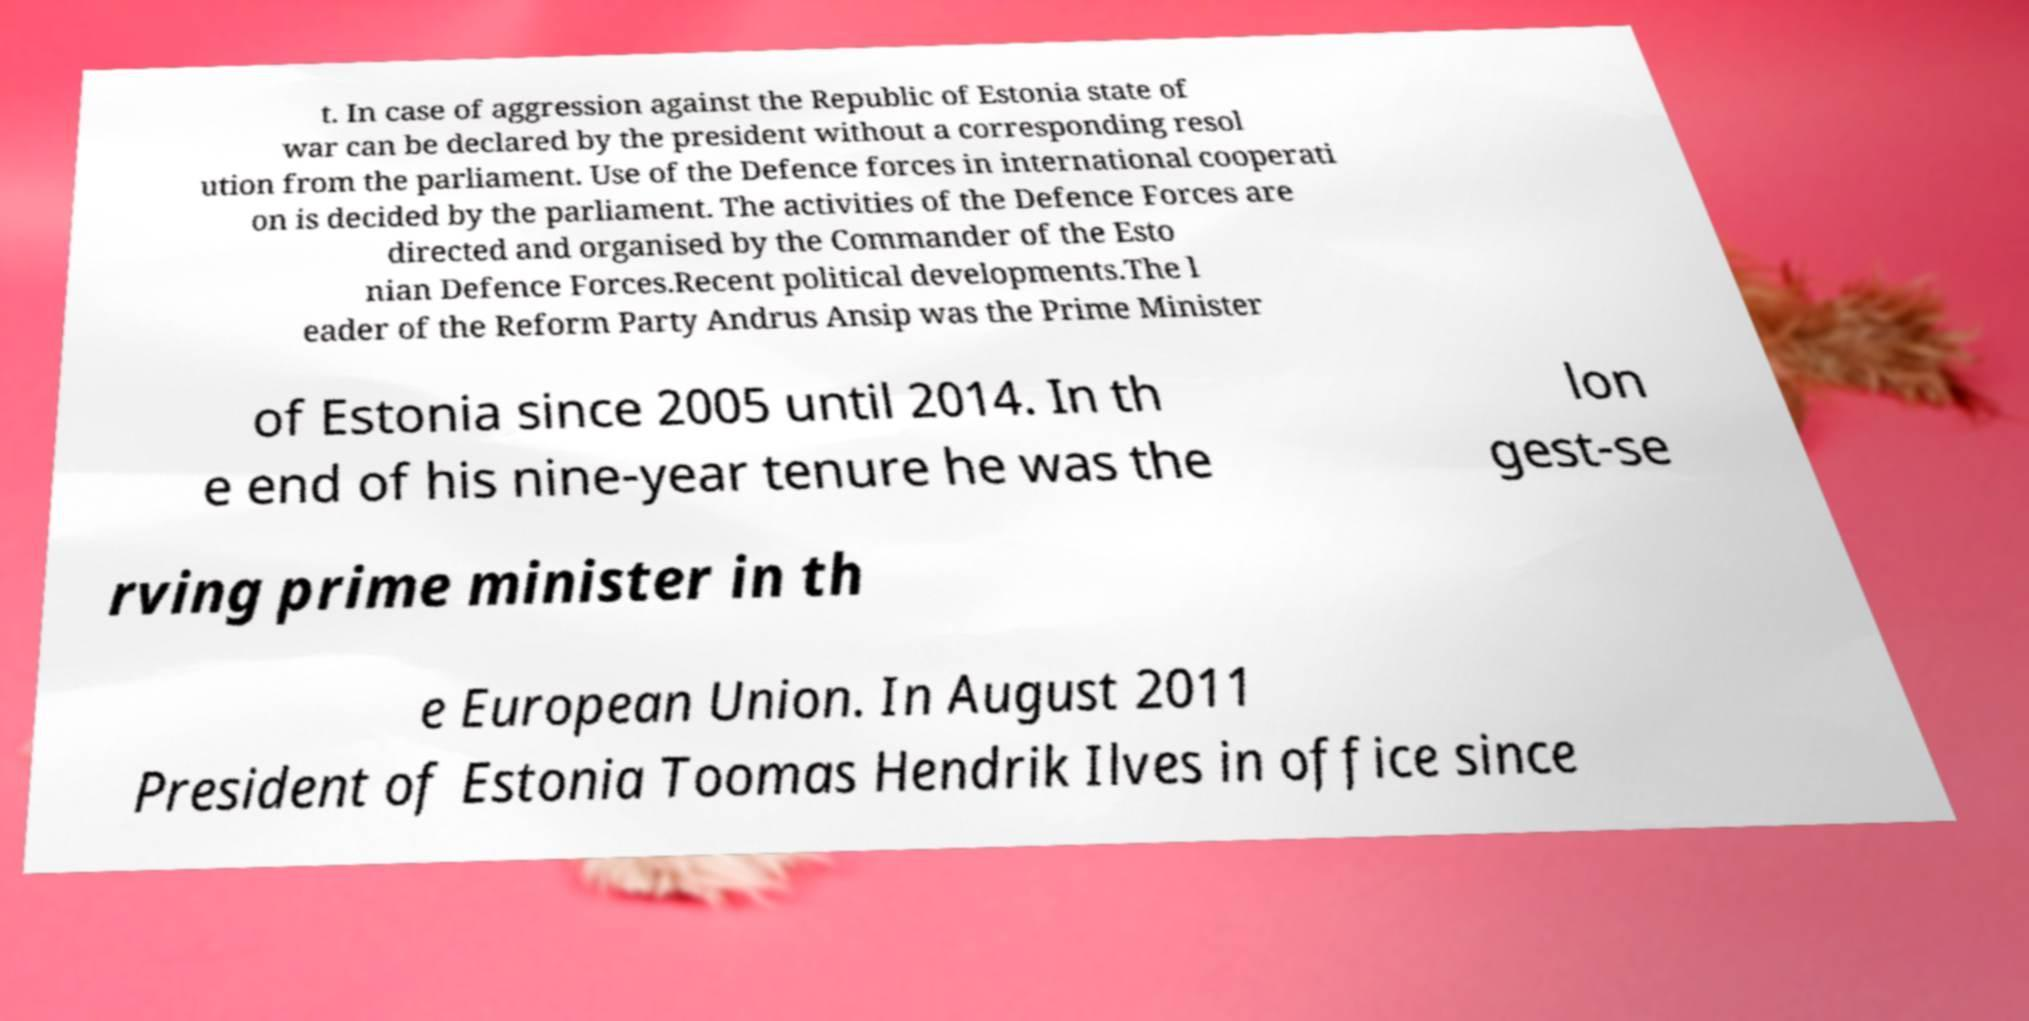I need the written content from this picture converted into text. Can you do that? t. In case of aggression against the Republic of Estonia state of war can be declared by the president without a corresponding resol ution from the parliament. Use of the Defence forces in international cooperati on is decided by the parliament. The activities of the Defence Forces are directed and organised by the Commander of the Esto nian Defence Forces.Recent political developments.The l eader of the Reform Party Andrus Ansip was the Prime Minister of Estonia since 2005 until 2014. In th e end of his nine-year tenure he was the lon gest-se rving prime minister in th e European Union. In August 2011 President of Estonia Toomas Hendrik Ilves in office since 